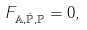<formula> <loc_0><loc_0><loc_500><loc_500>F _ { \mathbb { A } , \bar { \mathbb { P } } , \mathbb { P } } = 0 ,</formula> 